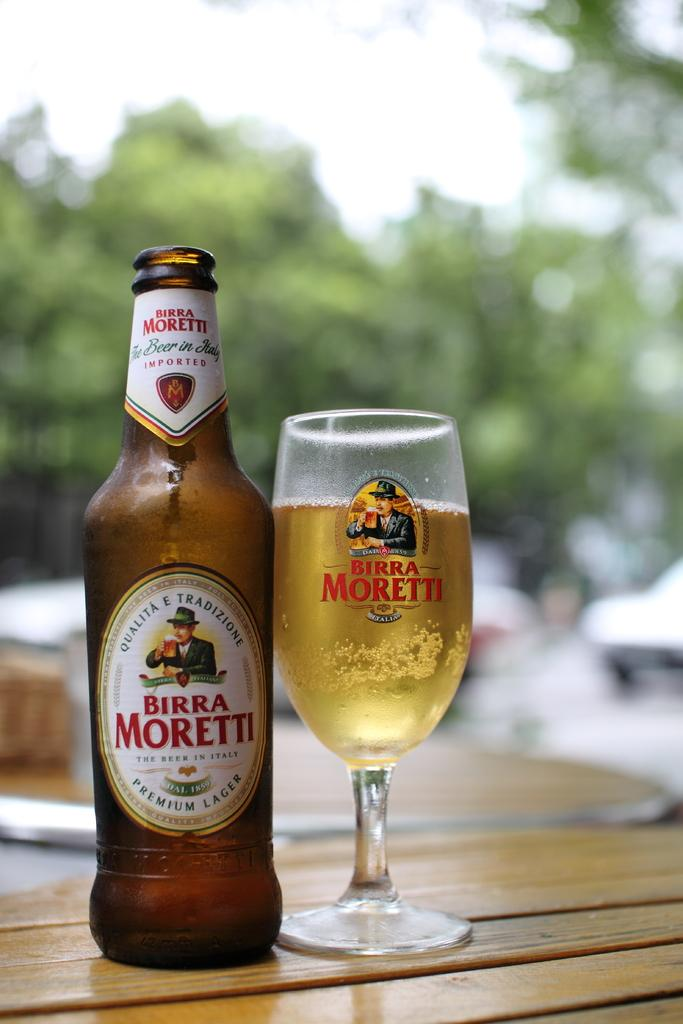<image>
Share a concise interpretation of the image provided. A bottle of Birra Moretti sits on a table next to a wine glass filled with the beverage. 